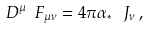<formula> <loc_0><loc_0><loc_500><loc_500>\ D ^ { \mu } \ F _ { \mu \nu } = 4 \pi \alpha _ { \ast } \, \ J _ { \nu } \, ,</formula> 